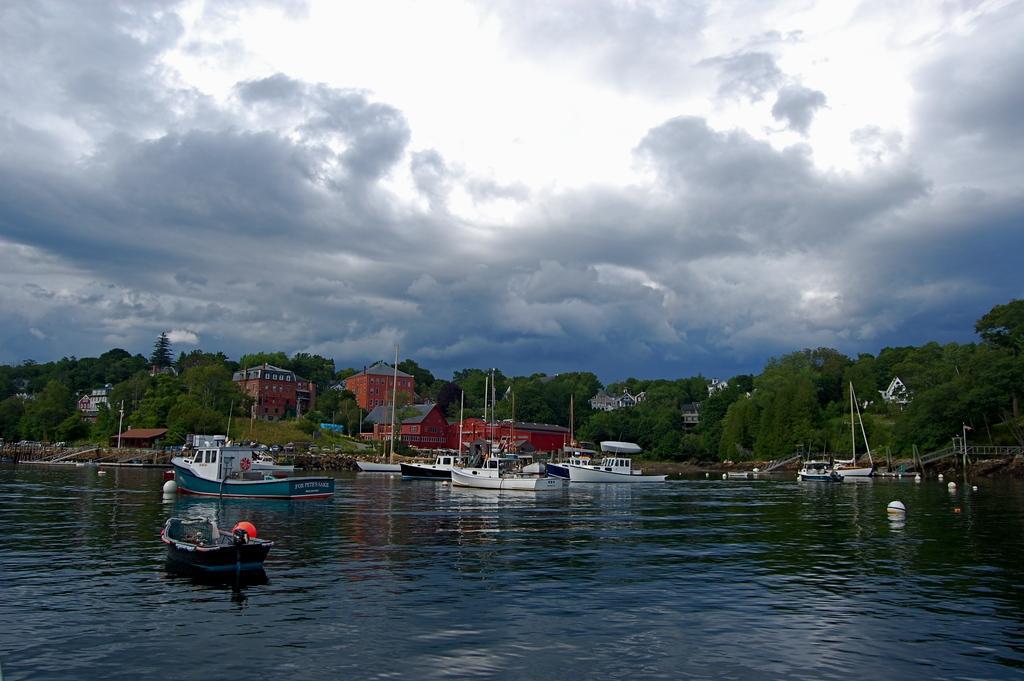Please provide a concise description of this image. In this image we can see there are boats on the water and at the back there are trees, buildings, bridge and the cloudy sky. 